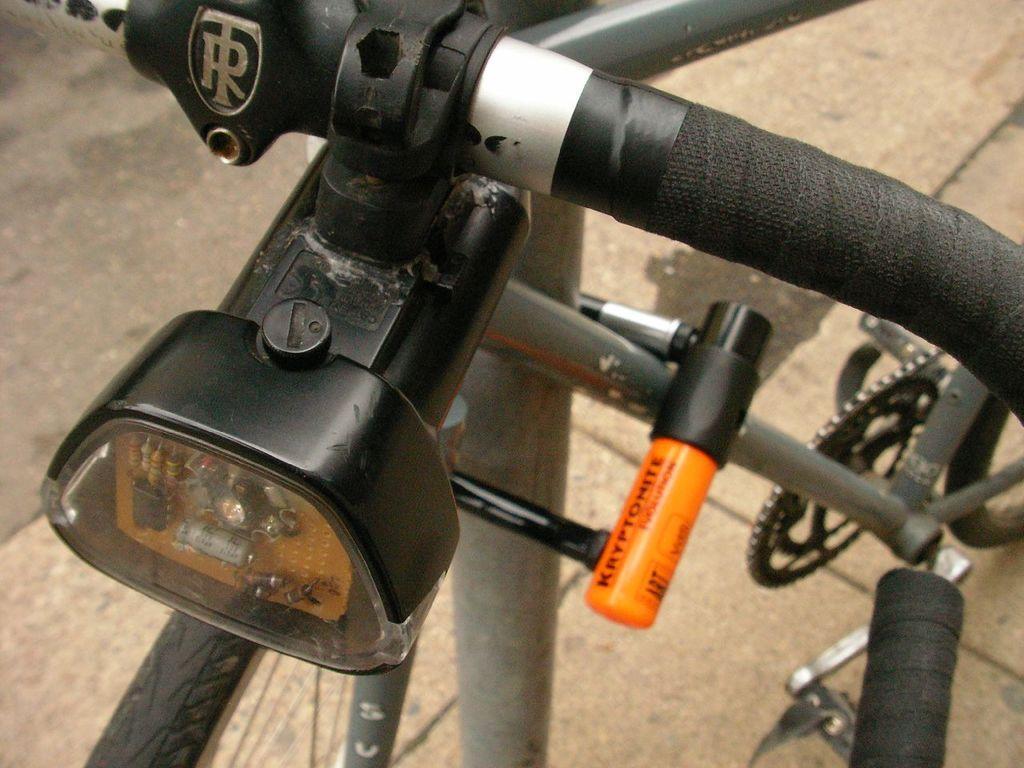Please provide a concise description of this image. In this image in the front there is a bicycle. 